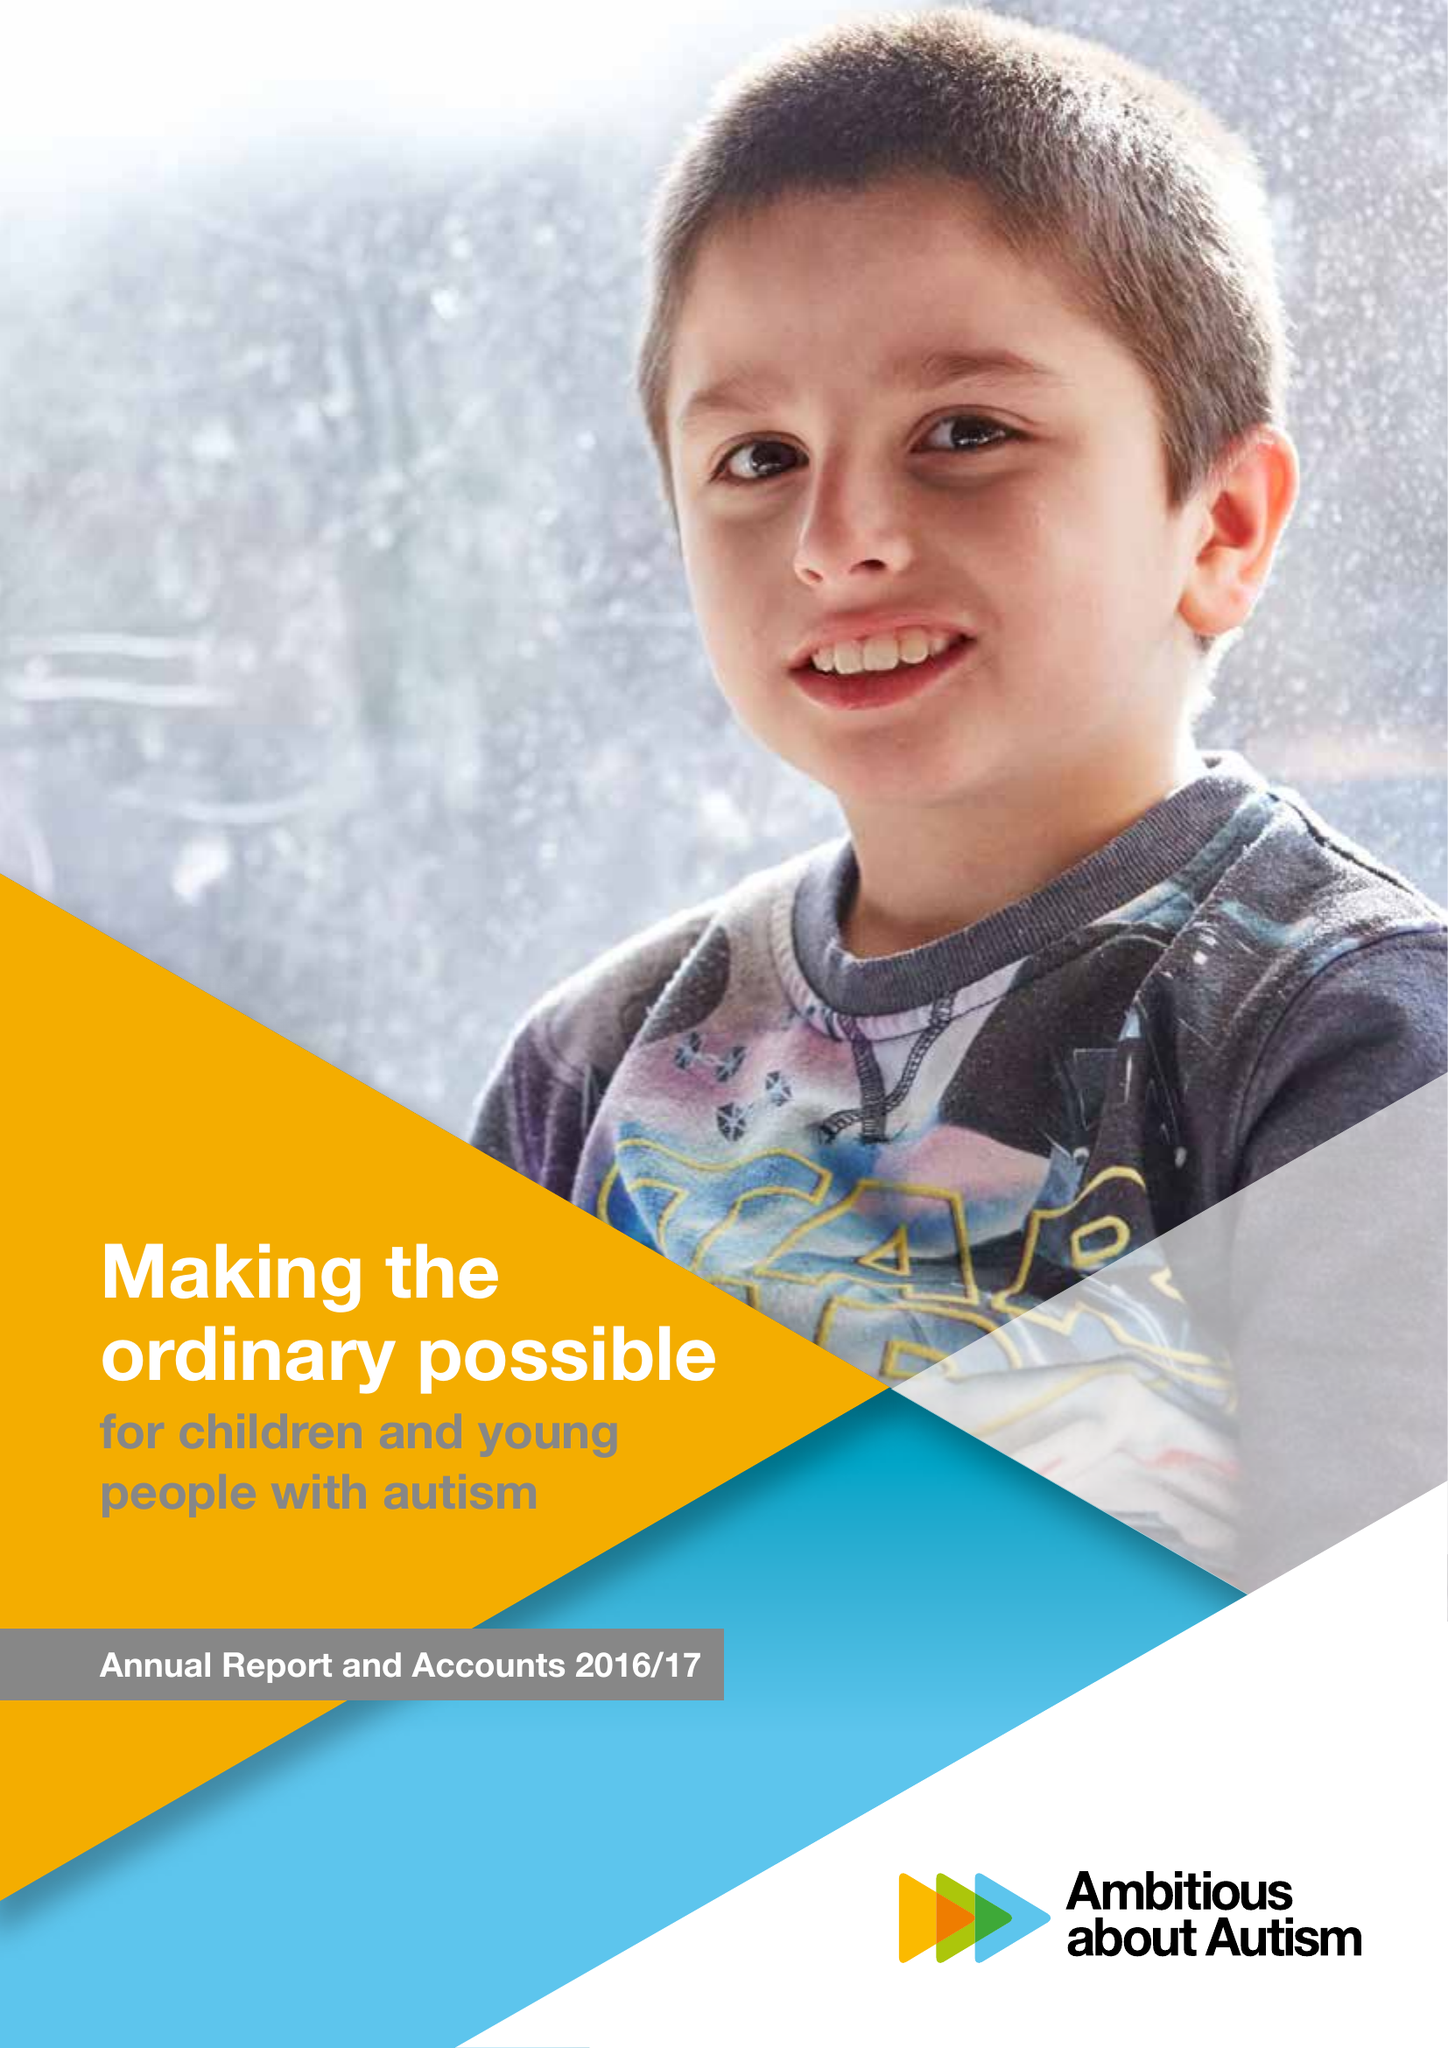What is the value for the report_date?
Answer the question using a single word or phrase. 2017-08-31 